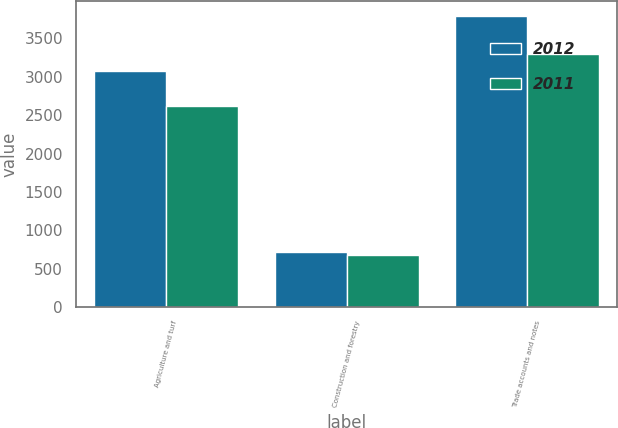Convert chart to OTSL. <chart><loc_0><loc_0><loc_500><loc_500><stacked_bar_chart><ecel><fcel>Agriculture and turf<fcel>Construction and forestry<fcel>Trade accounts and notes<nl><fcel>2012<fcel>3074<fcel>725<fcel>3799<nl><fcel>2011<fcel>2618<fcel>676<fcel>3294<nl></chart> 